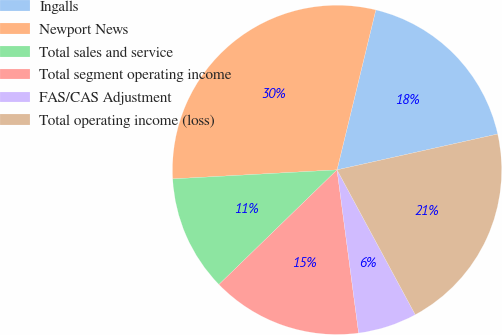Convert chart. <chart><loc_0><loc_0><loc_500><loc_500><pie_chart><fcel>Ingalls<fcel>Newport News<fcel>Total sales and service<fcel>Total segment operating income<fcel>FAS/CAS Adjustment<fcel>Total operating income (loss)<nl><fcel>17.72%<fcel>29.66%<fcel>11.39%<fcel>14.83%<fcel>5.79%<fcel>20.61%<nl></chart> 